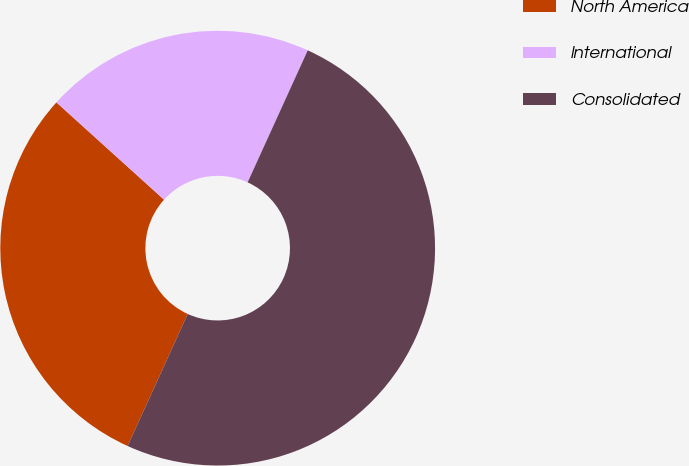<chart> <loc_0><loc_0><loc_500><loc_500><pie_chart><fcel>North America<fcel>International<fcel>Consolidated<nl><fcel>29.9%<fcel>20.1%<fcel>50.0%<nl></chart> 